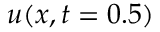<formula> <loc_0><loc_0><loc_500><loc_500>u ( x , t = 0 . 5 )</formula> 